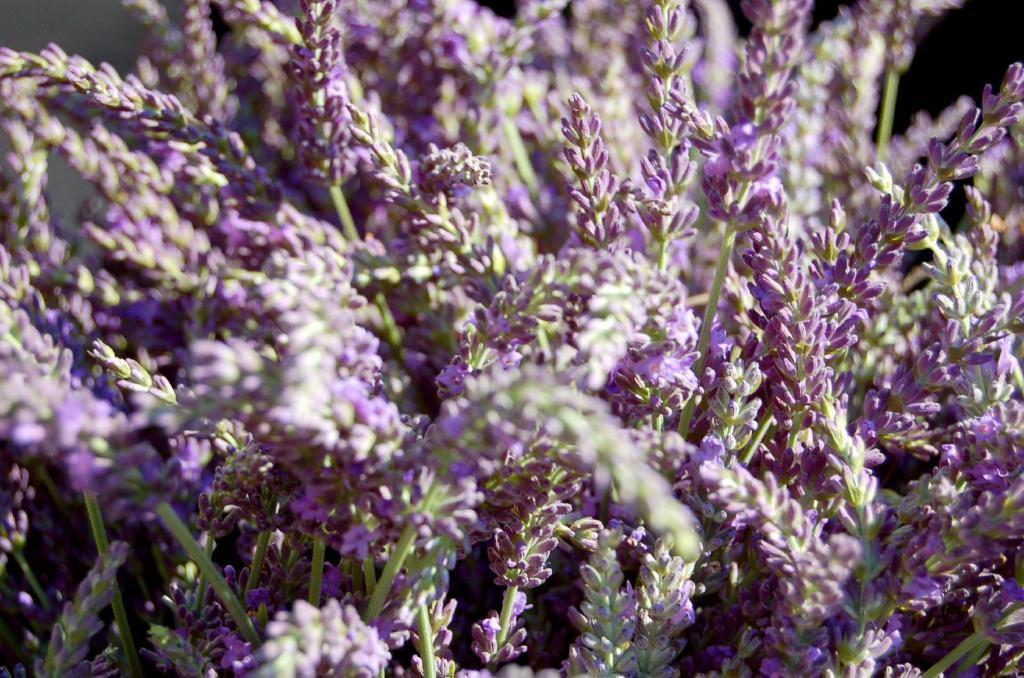Could you give a brief overview of what you see in this image? This is the zoom-in picture of a plant whose fruit are in purple color. 